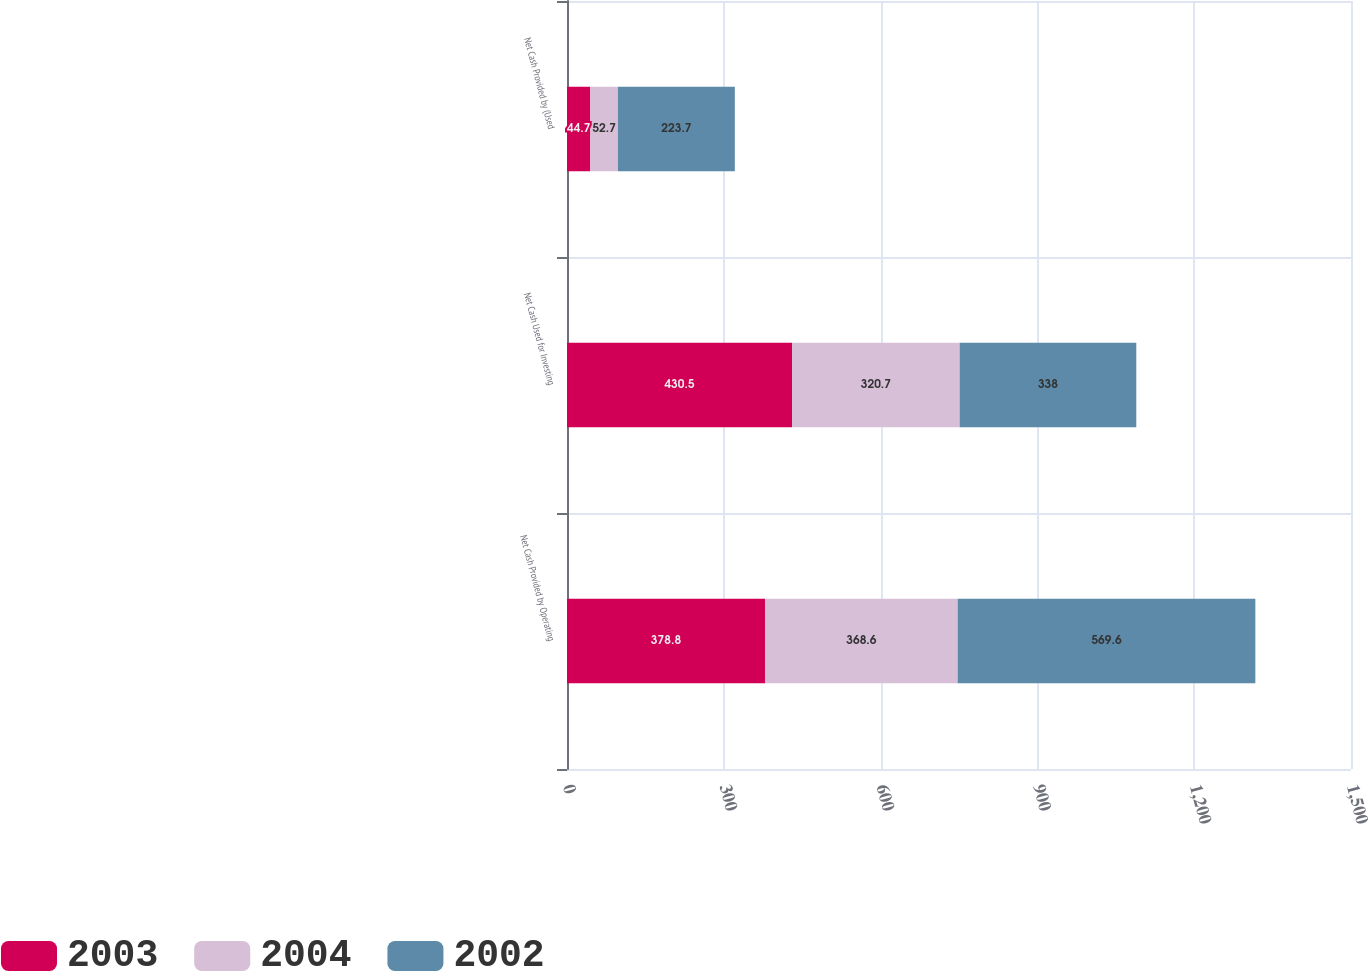<chart> <loc_0><loc_0><loc_500><loc_500><stacked_bar_chart><ecel><fcel>Net Cash Provided by Operating<fcel>Net Cash Used for Investing<fcel>Net Cash Provided by (Used<nl><fcel>2003<fcel>378.8<fcel>430.5<fcel>44.7<nl><fcel>2004<fcel>368.6<fcel>320.7<fcel>52.7<nl><fcel>2002<fcel>569.6<fcel>338<fcel>223.7<nl></chart> 